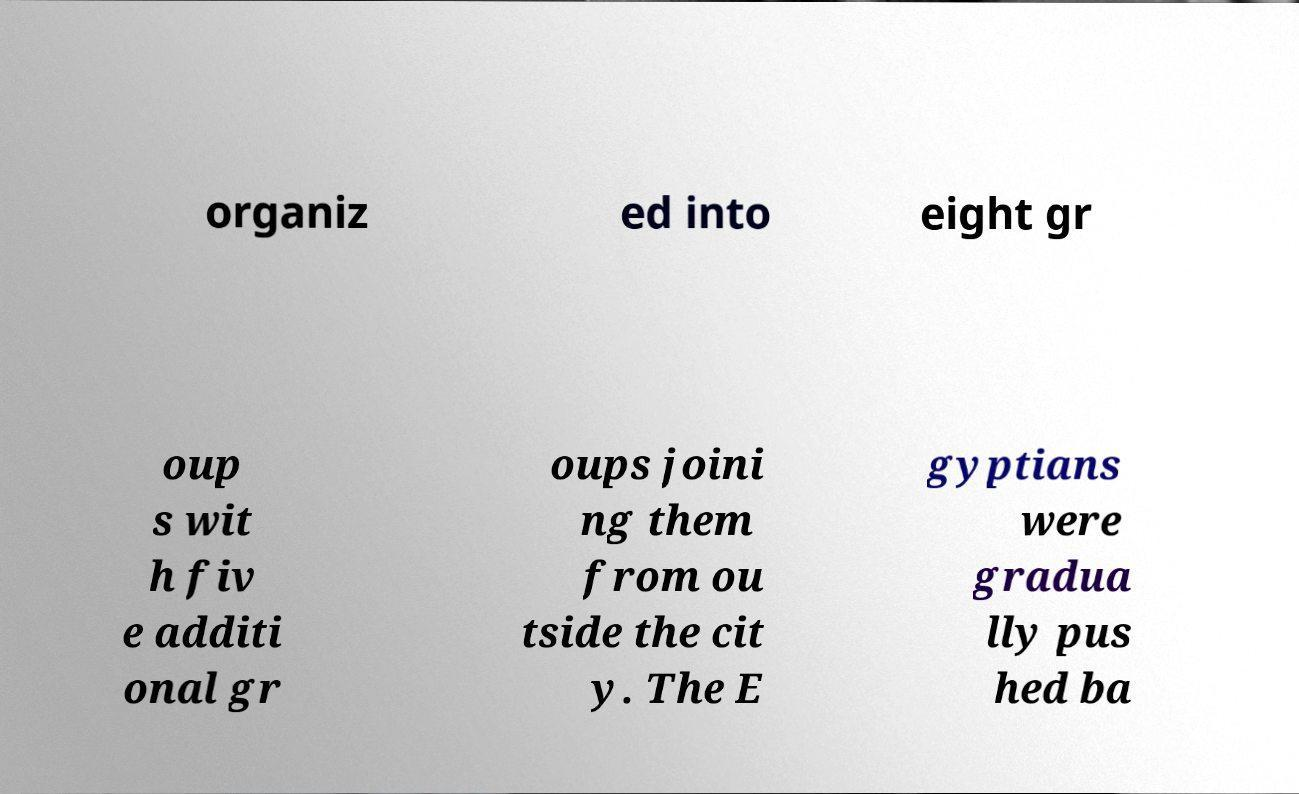I need the written content from this picture converted into text. Can you do that? organiz ed into eight gr oup s wit h fiv e additi onal gr oups joini ng them from ou tside the cit y. The E gyptians were gradua lly pus hed ba 